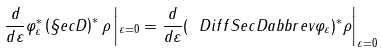Convert formula to latex. <formula><loc_0><loc_0><loc_500><loc_500>\frac { d } { d \varepsilon } \varphi _ { \varepsilon } ^ { * } \left ( \S e c D \right ) ^ { * } \rho \left | _ { \varepsilon = 0 } = \frac { d } { d \varepsilon } ( \ D i f f S e c D a b b r e v { \varphi _ { \varepsilon } } ) ^ { * } \rho \right | _ { \varepsilon = 0 }</formula> 